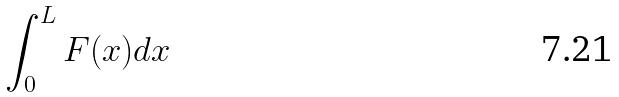<formula> <loc_0><loc_0><loc_500><loc_500>\int _ { 0 } ^ { L } F ( x ) d x</formula> 